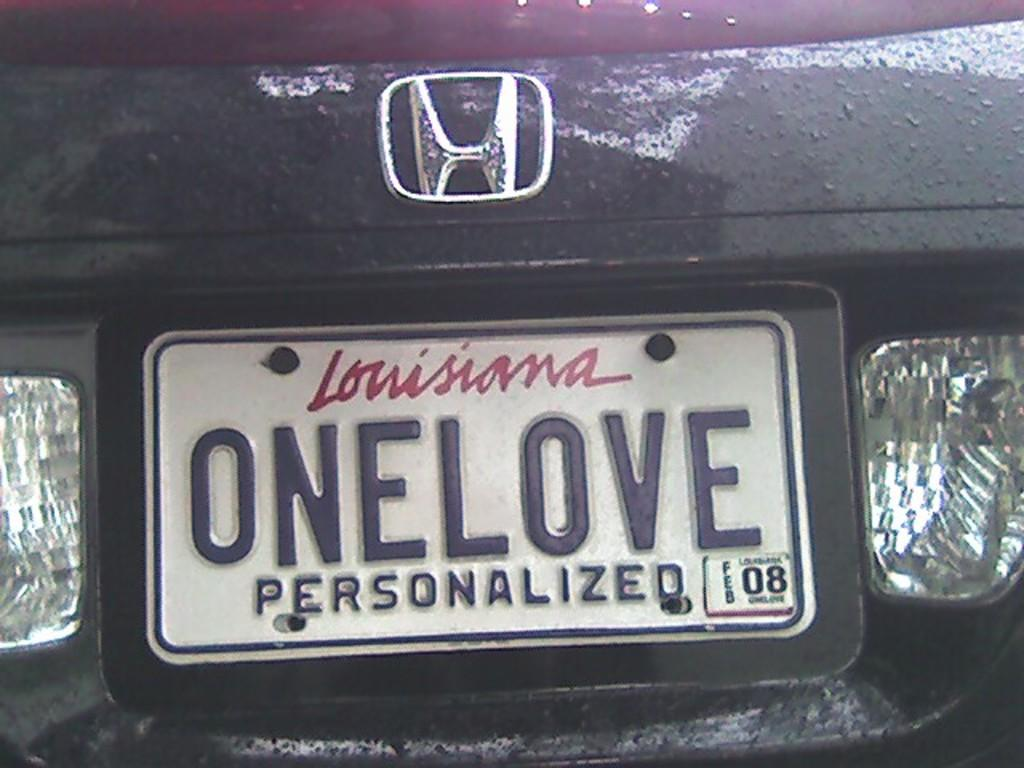<image>
Give a short and clear explanation of the subsequent image. A close up of a Louisiana license plate that says ONELOVE on it. 